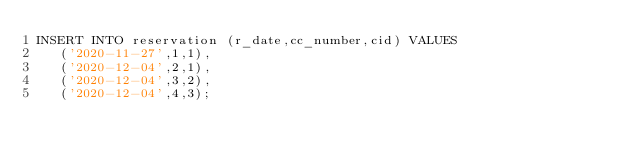Convert code to text. <code><loc_0><loc_0><loc_500><loc_500><_SQL_>INSERT INTO reservation (r_date,cc_number,cid) VALUES
	 ('2020-11-27',1,1),
	 ('2020-12-04',2,1),
	 ('2020-12-04',3,2),
	 ('2020-12-04',4,3);</code> 